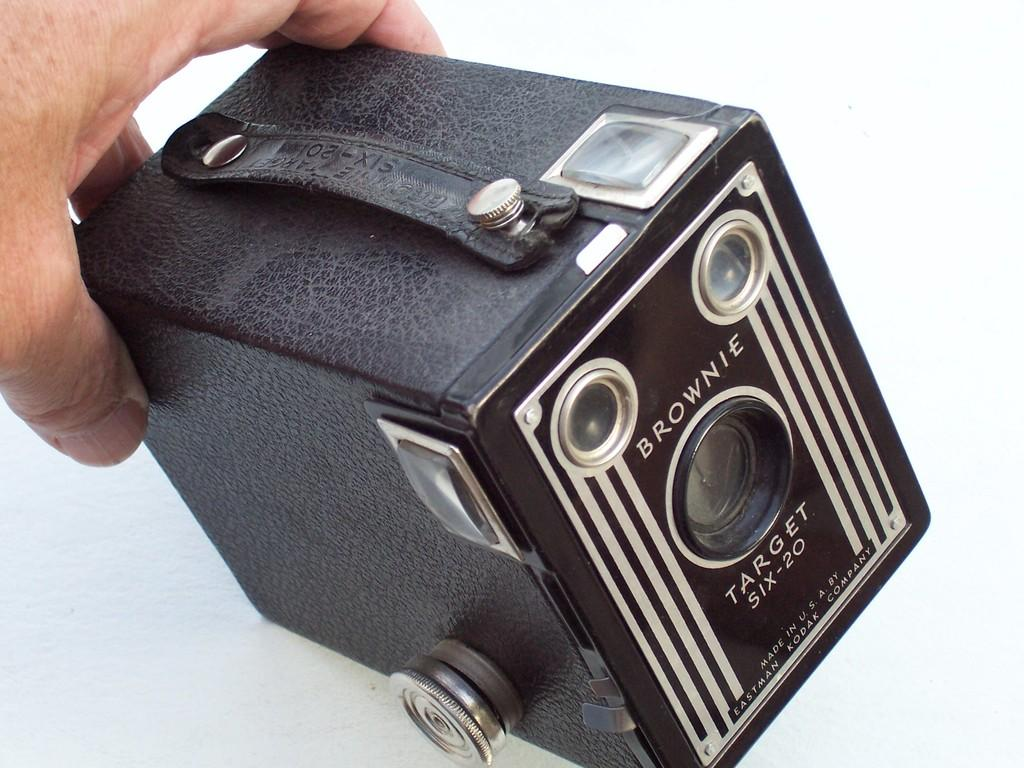What can be seen in the image? There is a person's hand in the image. What is the hand holding? The hand is holding a vintage camera. What type of protest is being held in the image? There is no protest present in the image; it only shows a person's hand holding a vintage camera. 